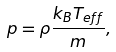Convert formula to latex. <formula><loc_0><loc_0><loc_500><loc_500>p = \rho \frac { k _ { B } T _ { e f f } } { m } ,</formula> 